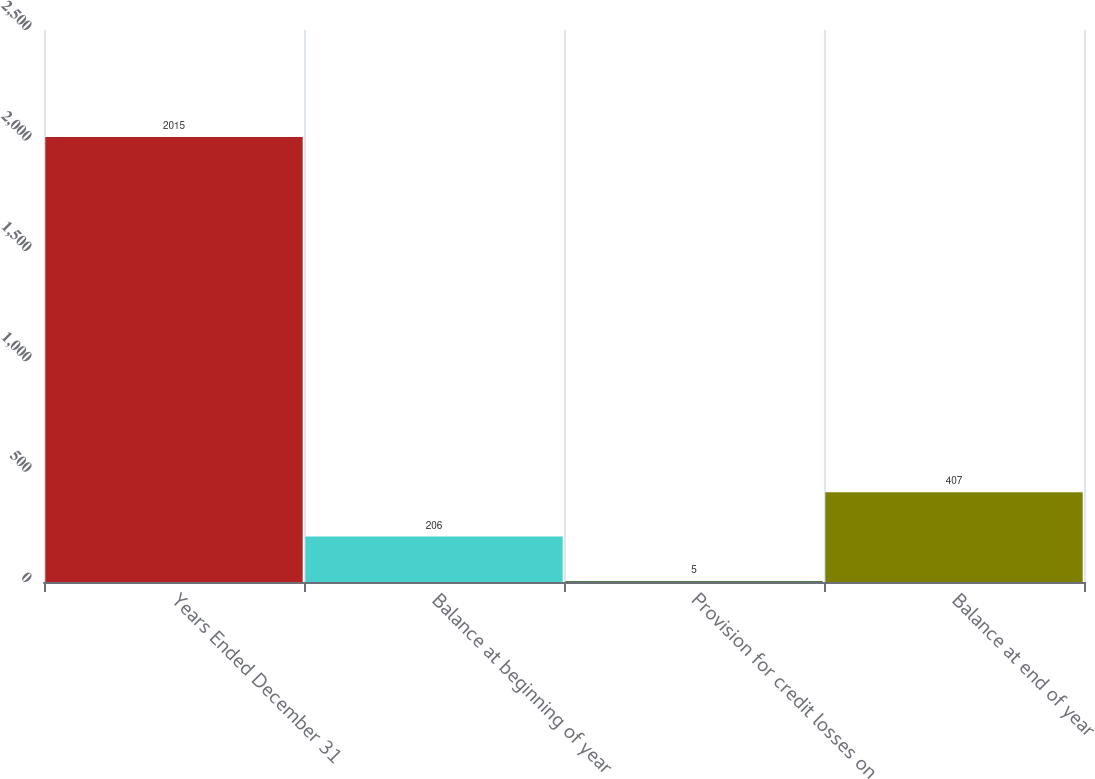Convert chart to OTSL. <chart><loc_0><loc_0><loc_500><loc_500><bar_chart><fcel>Years Ended December 31<fcel>Balance at beginning of year<fcel>Provision for credit losses on<fcel>Balance at end of year<nl><fcel>2015<fcel>206<fcel>5<fcel>407<nl></chart> 